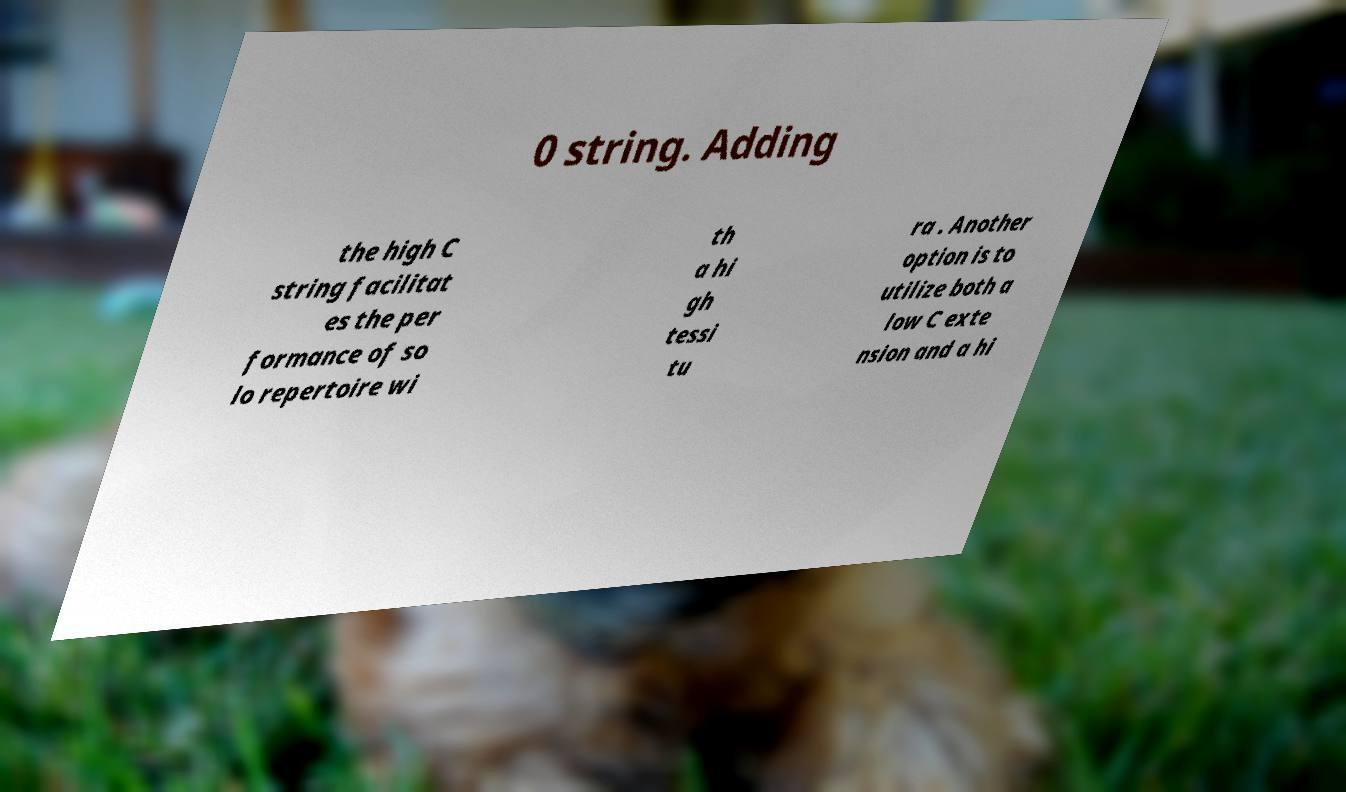What messages or text are displayed in this image? I need them in a readable, typed format. 0 string. Adding the high C string facilitat es the per formance of so lo repertoire wi th a hi gh tessi tu ra . Another option is to utilize both a low C exte nsion and a hi 